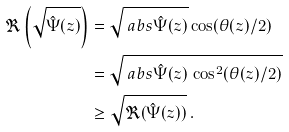<formula> <loc_0><loc_0><loc_500><loc_500>\Re \left ( \sqrt { \hat { \Psi } ( z ) } \right ) & = \sqrt { \ a b s { \hat { \Psi } ( z ) } } \cos ( \theta ( z ) / 2 ) \\ & = \sqrt { \ a b s { \hat { \Psi } ( z ) } \, \cos ^ { 2 } ( \theta ( z ) / 2 ) } \\ & \geq \sqrt { \Re ( \hat { \Psi } ( z ) ) } \, .</formula> 